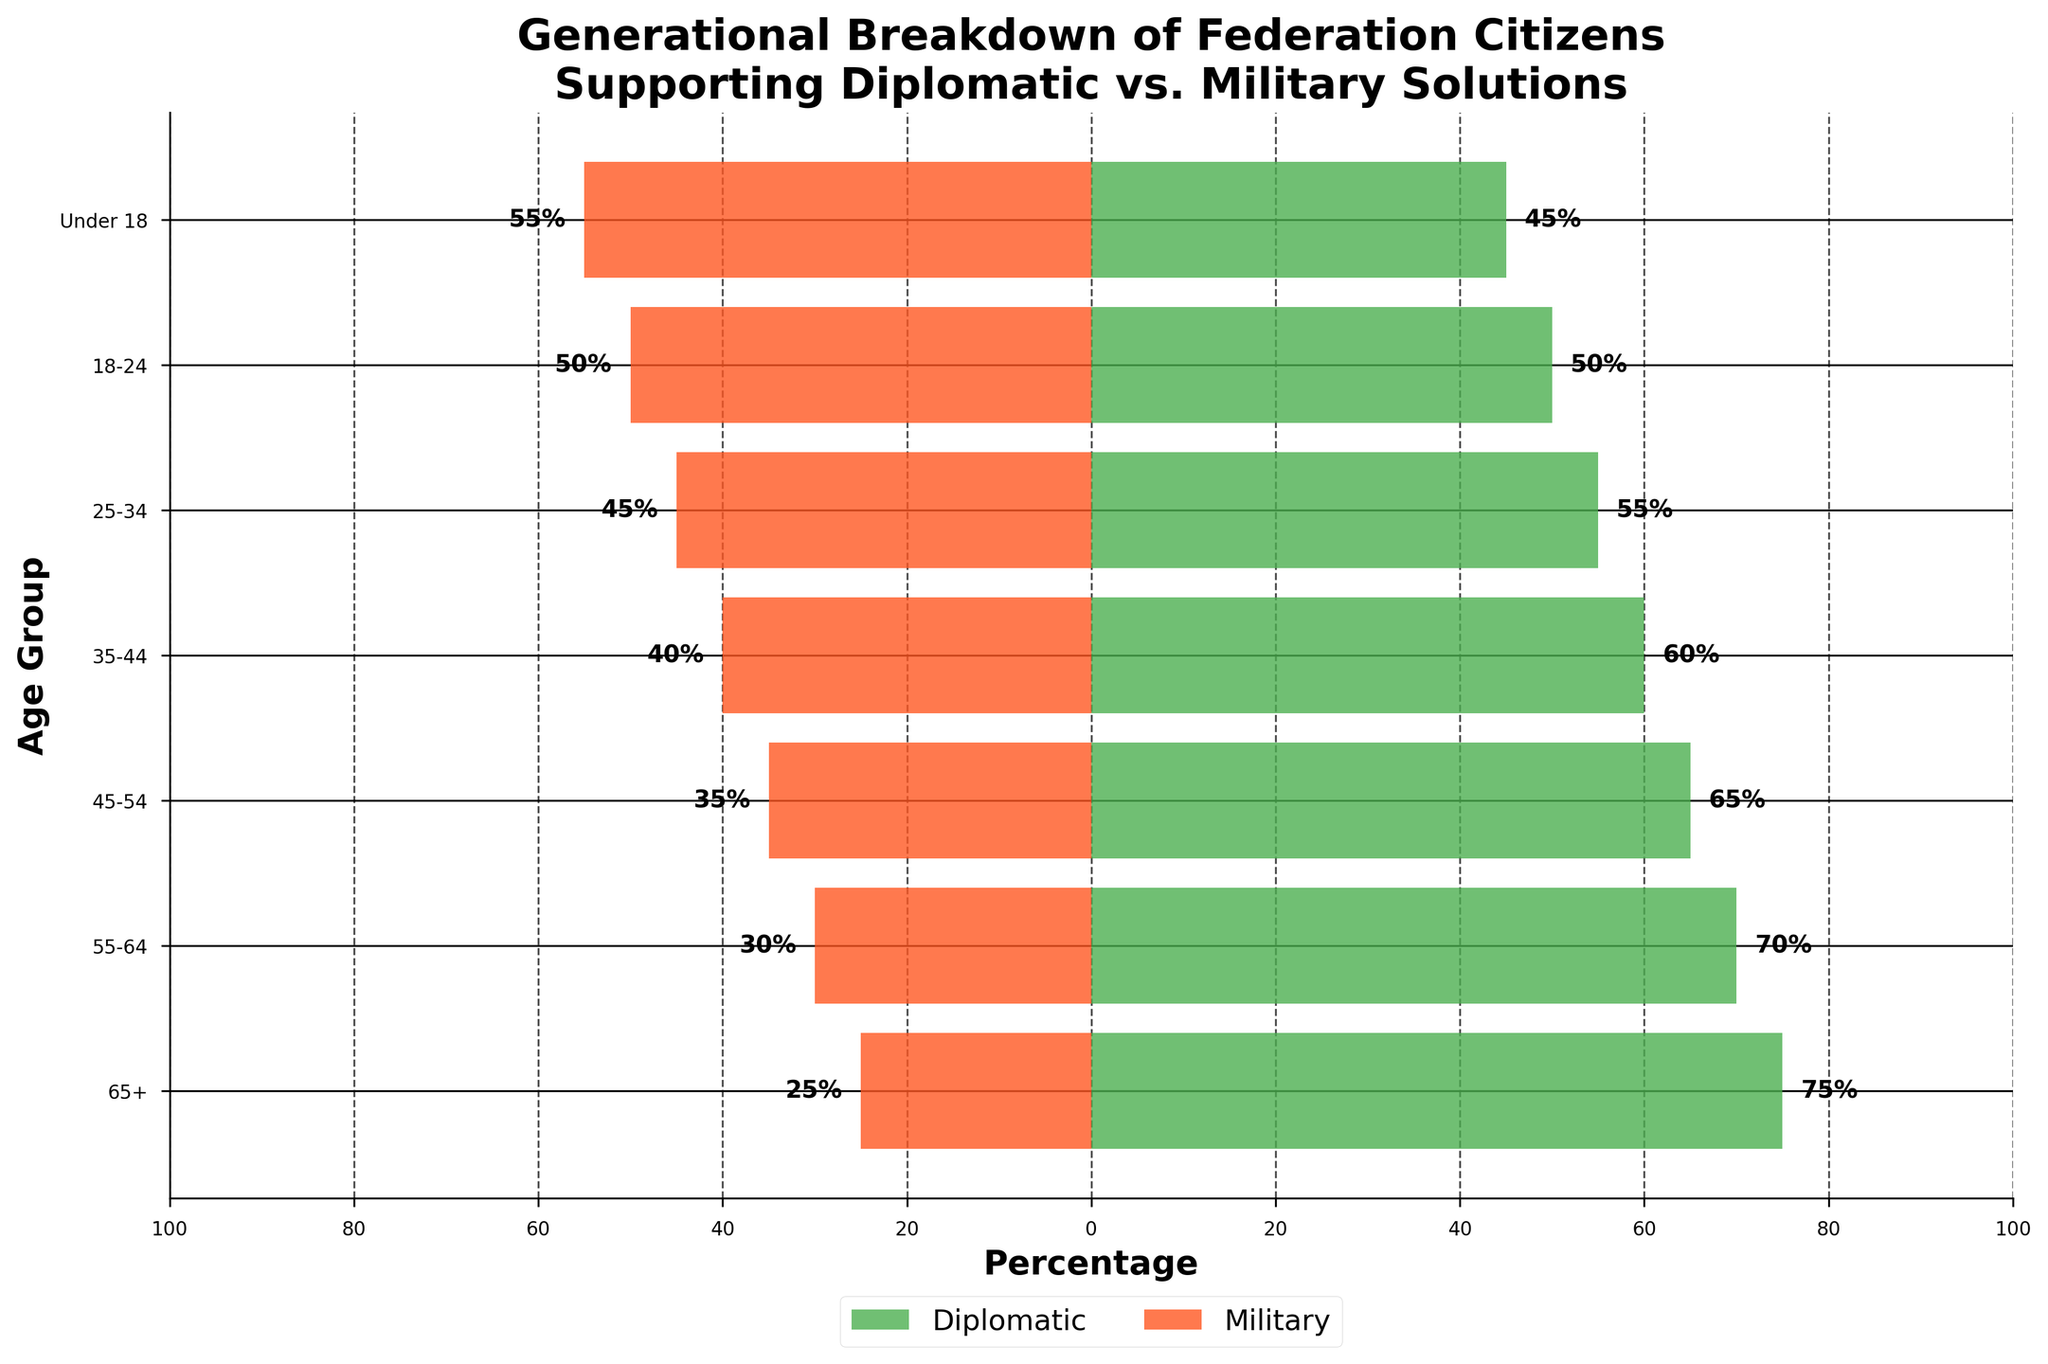what is the title of the figure? The title of the figure is displayed at the top and describes what the figure is about.
Answer: Generational Breakdown of Federation Citizens Supporting Diplomatic vs. Military Solutions which age group shows the highest support for diplomatic solutions? Look at the longest bar on the diplomatic side (left) to find the age group with the highest percentage.
Answer: 65+ between the age groups 25-34 and 45-54, which has greater support for military solutions? Compare the lengths of the military support bars (right side) for the 25-34 and 45-54 age groups.
Answer: 25-34 what is the total percentage supporting diplomatic solutions for those aged 45 and above? Sum the percentages from the age groups 45-54, 55-64, and 65+ for diplomatic solutions (left side). 65% + 70% + 75% = 210%.
Answer: 210% how does the support for diplomatic solutions change from the "Under 18" group to the "18-24" group? Calculate the difference in percentage between the "18-24" and "Under 18" groups for diplomatic solutions. 50% - 45% = 5%
Answer: Increases by 5% which side of the chart shows military solution support? Observe the direction in which the bars representing military solutions are plotted.
Answer: right what is the percentage difference in diplomatic support between the "35-44" and "65+" age groups? Subtract the percentage for the "35-44" group from the percentage for the "65+" group for diplomatic solutions. 75% - 60% = 15%
Answer: 15% by how much does military support increase from the "18-24" group to the "Under 18" group? Calculate the difference in percentage between the "Under 18" and "18-24" groups for military solutions. 55% - 50% = 5%
Answer: Increases by 5% which age group shows an equal percentage of support for both diplomatic and military solutions? Identify the age group where the lengths of the bars for diplomatic and military solutions are equal.
Answer: 18-24 